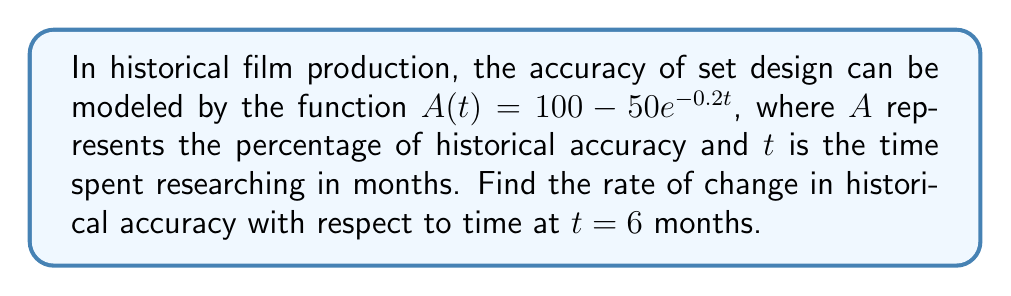Solve this math problem. To find the rate of change in historical accuracy with respect to time, we need to find the derivative of $A(t)$ and then evaluate it at $t = 6$.

Step 1: Find the derivative of $A(t)$
$$A(t) = 100 - 50e^{-0.2t}$$
Using the chain rule, we get:
$$A'(t) = 0 - 50 \cdot (-0.2e^{-0.2t})$$
$$A'(t) = 10e^{-0.2t}$$

Step 2: Evaluate $A'(t)$ at $t = 6$
$$A'(6) = 10e^{-0.2(6)}$$
$$A'(6) = 10e^{-1.2}$$
$$A'(6) \approx 3.01$$ (rounded to two decimal places)

This means that after 6 months of research, the historical accuracy of the set design is increasing at a rate of approximately 3.01 percentage points per month.
Answer: $3.01$ percentage points per month 